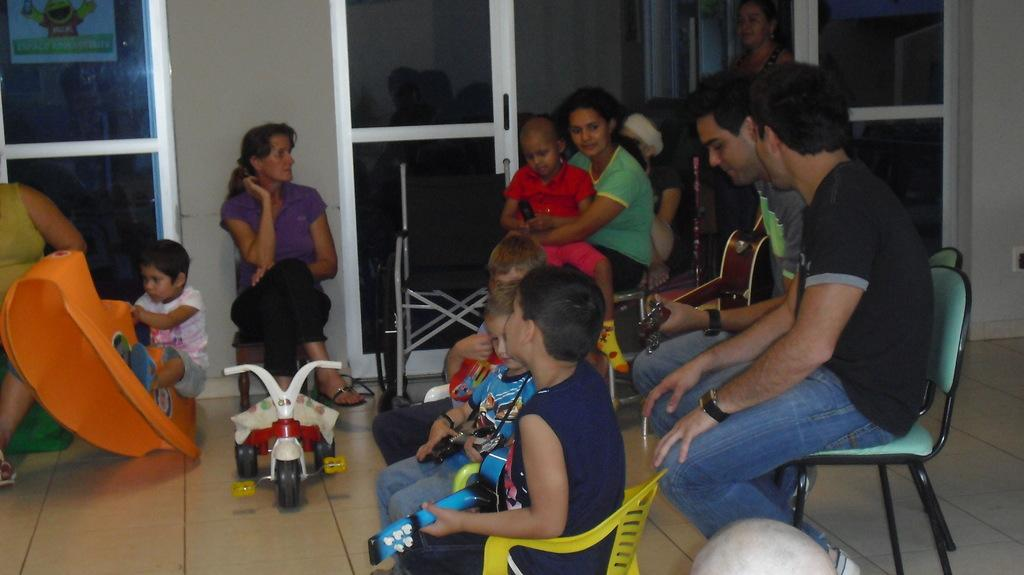What is happening in the image involving a group of people? There is a group of people in the image, and they are sitting on chairs. Can you describe any other activities happening in the image? Yes, there is a kid playing with a toy, and a person is playing the guitar. Where is the tent set up in the image? There is no tent present in the image. What type of voyage are the people in the image embarking on? There is no indication of a voyage in the image; it simply shows a group of people sitting on chairs, a kid playing with a toy, and a person playing the guitar. 